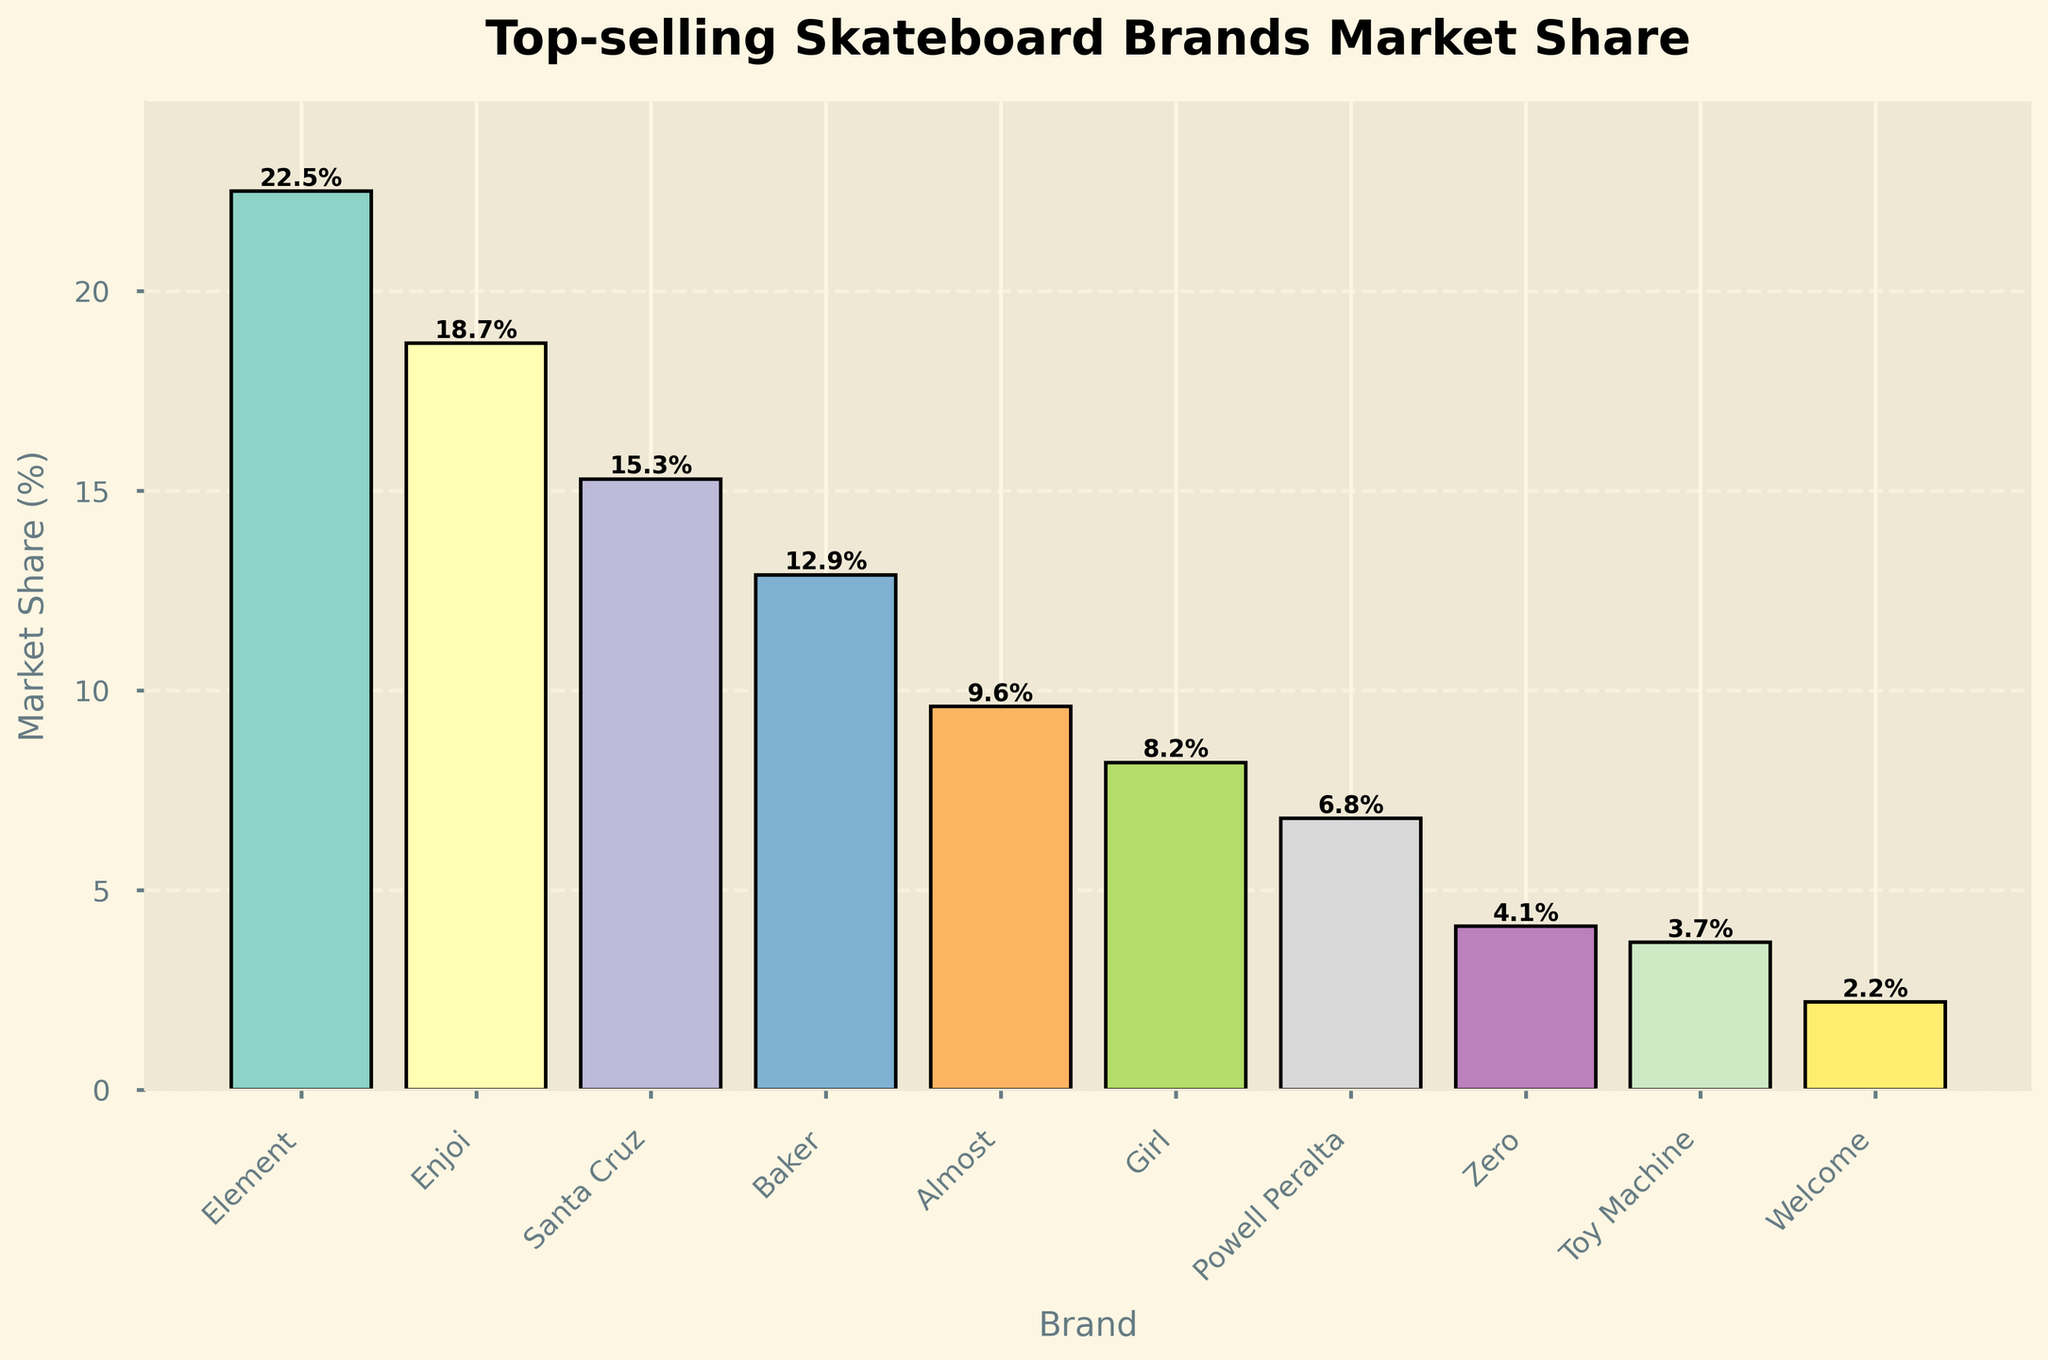Which brand has the highest market share? The brand with the highest bar in the chart is the one with the highest market share. From the figure, the "Element" bar is the tallest.
Answer: Element Which two brands have the closest market share? Look for bars of similar height. The bars for "Zero" and "Toy Machine" appear closest in height.
Answer: Zero and Toy Machine What is the total market share of the top three brands? Sum the market shares of the top three brands. Element (22.5) + Enjoi (18.7) + Santa Cruz (15.3) equals 56.5%.
Answer: 56.5% How much more market share does Element have compared to Girl? Subtract the market share of Girl from Element. Element has 22.5% and Girl has 8.2%, so 22.5% - 8.2% = 14.3%.
Answer: 14.3% Which brand has the lowest market share? The brand with the shortest bar in the chart has the lowest market share, which is "Welcome", with the shortest bar.
Answer: Welcome By how much does Enjoi's market share exceed Baker's? Subtract Baker’s market share from Enjoi’s. Enjoi has 18.7% and Baker has 12.9%, so 18.7% - 12.9% = 5.8%.
Answer: 5.8% What is the average market share of the brands? Sum all market shares and divide by the number of brands. Total sum is 104.0%, and there are 10 brands, so 104.0% / 10 = 10.4%.
Answer: 10.4% Is the market share of Santa Cruz greater than the combined market shares of Zero and Toy Machine? Compare Santa Cruz's market share (15.3%) to the sum of Zero and Toy Machine (4.1% + 3.7% = 7.8%). 15.3% is greater than 7.8%.
Answer: Yes What is the combined market share of the brands with less than 10% market share? Sum the market shares of Almost (9.6), Girl (8.2), Powell Peralta (6.8), Zero (4.1), Toy Machine (3.7), and Welcome (2.2). Total = 34.6%.
Answer: 34.6% Which brand's market share is closest to the average market share of 10.4%? Compare each brand's market share to 10.4% and find the closest one. Almost's market share of 9.6% is the closest to 10.4%.
Answer: Almost 